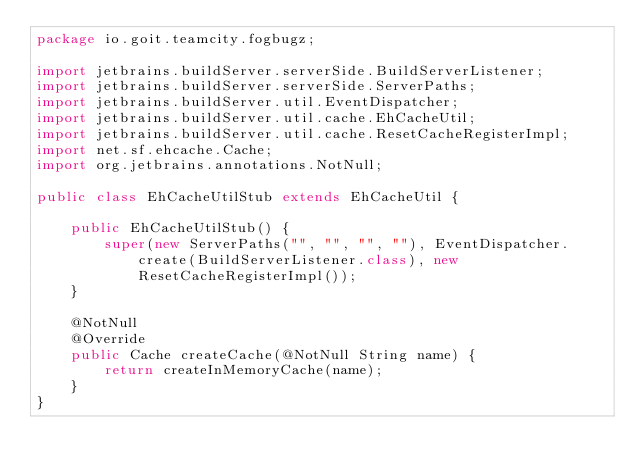Convert code to text. <code><loc_0><loc_0><loc_500><loc_500><_Java_>package io.goit.teamcity.fogbugz;

import jetbrains.buildServer.serverSide.BuildServerListener;
import jetbrains.buildServer.serverSide.ServerPaths;
import jetbrains.buildServer.util.EventDispatcher;
import jetbrains.buildServer.util.cache.EhCacheUtil;
import jetbrains.buildServer.util.cache.ResetCacheRegisterImpl;
import net.sf.ehcache.Cache;
import org.jetbrains.annotations.NotNull;

public class EhCacheUtilStub extends EhCacheUtil {

    public EhCacheUtilStub() {
        super(new ServerPaths("", "", "", ""), EventDispatcher.create(BuildServerListener.class), new ResetCacheRegisterImpl());
    }

    @NotNull
    @Override
    public Cache createCache(@NotNull String name) {
        return createInMemoryCache(name);
    }
}
</code> 